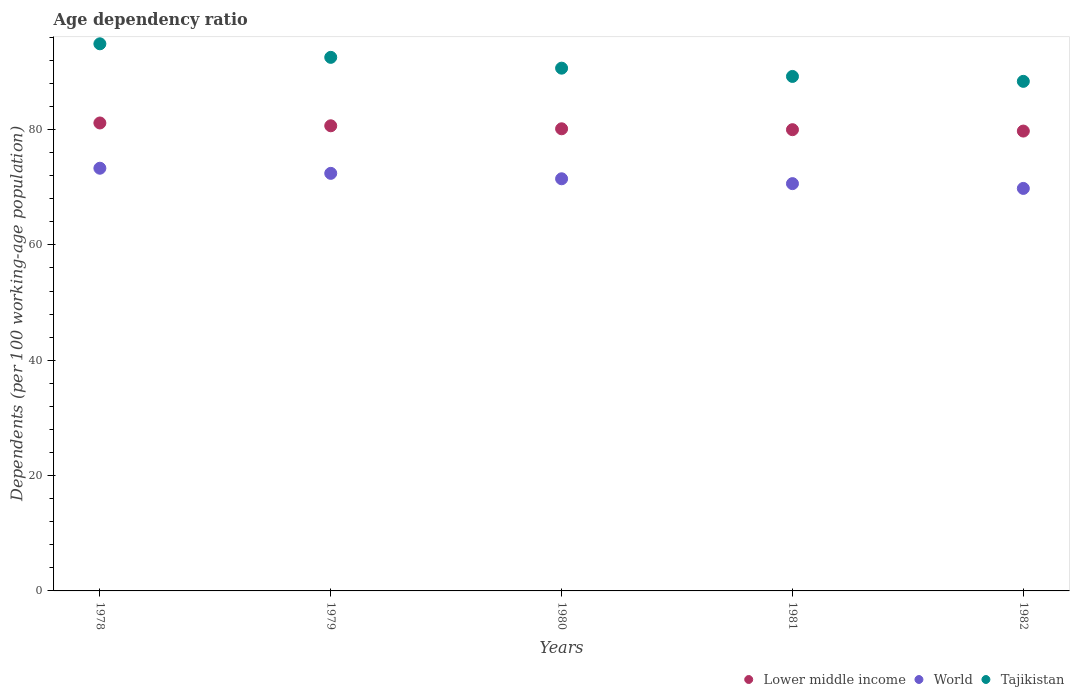What is the age dependency ratio in in Tajikistan in 1979?
Provide a short and direct response. 92.51. Across all years, what is the maximum age dependency ratio in in Tajikistan?
Ensure brevity in your answer.  94.86. Across all years, what is the minimum age dependency ratio in in Lower middle income?
Your answer should be compact. 79.73. In which year was the age dependency ratio in in Tajikistan maximum?
Keep it short and to the point. 1978. In which year was the age dependency ratio in in Tajikistan minimum?
Keep it short and to the point. 1982. What is the total age dependency ratio in in World in the graph?
Provide a succinct answer. 357.56. What is the difference between the age dependency ratio in in Tajikistan in 1980 and that in 1982?
Keep it short and to the point. 2.29. What is the difference between the age dependency ratio in in Lower middle income in 1978 and the age dependency ratio in in Tajikistan in 1982?
Your answer should be compact. -7.22. What is the average age dependency ratio in in Lower middle income per year?
Keep it short and to the point. 80.32. In the year 1981, what is the difference between the age dependency ratio in in Lower middle income and age dependency ratio in in World?
Your answer should be very brief. 9.35. What is the ratio of the age dependency ratio in in Tajikistan in 1980 to that in 1981?
Offer a terse response. 1.02. Is the difference between the age dependency ratio in in Lower middle income in 1978 and 1980 greater than the difference between the age dependency ratio in in World in 1978 and 1980?
Make the answer very short. No. What is the difference between the highest and the second highest age dependency ratio in in Tajikistan?
Your answer should be very brief. 2.35. What is the difference between the highest and the lowest age dependency ratio in in World?
Offer a very short reply. 3.5. In how many years, is the age dependency ratio in in Tajikistan greater than the average age dependency ratio in in Tajikistan taken over all years?
Provide a short and direct response. 2. Is the age dependency ratio in in World strictly greater than the age dependency ratio in in Tajikistan over the years?
Offer a terse response. No. Is the age dependency ratio in in Lower middle income strictly less than the age dependency ratio in in Tajikistan over the years?
Provide a succinct answer. Yes. How many dotlines are there?
Provide a succinct answer. 3. How many years are there in the graph?
Offer a terse response. 5. Does the graph contain grids?
Your answer should be compact. No. Where does the legend appear in the graph?
Offer a terse response. Bottom right. How are the legend labels stacked?
Make the answer very short. Horizontal. What is the title of the graph?
Make the answer very short. Age dependency ratio. What is the label or title of the X-axis?
Your response must be concise. Years. What is the label or title of the Y-axis?
Keep it short and to the point. Dependents (per 100 working-age population). What is the Dependents (per 100 working-age population) of Lower middle income in 1978?
Your answer should be very brief. 81.14. What is the Dependents (per 100 working-age population) of World in 1978?
Make the answer very short. 73.29. What is the Dependents (per 100 working-age population) of Tajikistan in 1978?
Offer a terse response. 94.86. What is the Dependents (per 100 working-age population) of Lower middle income in 1979?
Offer a very short reply. 80.65. What is the Dependents (per 100 working-age population) of World in 1979?
Your answer should be compact. 72.4. What is the Dependents (per 100 working-age population) in Tajikistan in 1979?
Keep it short and to the point. 92.51. What is the Dependents (per 100 working-age population) of Lower middle income in 1980?
Ensure brevity in your answer.  80.13. What is the Dependents (per 100 working-age population) of World in 1980?
Provide a succinct answer. 71.46. What is the Dependents (per 100 working-age population) in Tajikistan in 1980?
Your answer should be compact. 90.64. What is the Dependents (per 100 working-age population) of Lower middle income in 1981?
Your response must be concise. 79.97. What is the Dependents (per 100 working-age population) of World in 1981?
Provide a succinct answer. 70.62. What is the Dependents (per 100 working-age population) of Tajikistan in 1981?
Give a very brief answer. 89.2. What is the Dependents (per 100 working-age population) in Lower middle income in 1982?
Offer a terse response. 79.73. What is the Dependents (per 100 working-age population) in World in 1982?
Make the answer very short. 69.79. What is the Dependents (per 100 working-age population) of Tajikistan in 1982?
Make the answer very short. 88.35. Across all years, what is the maximum Dependents (per 100 working-age population) of Lower middle income?
Your answer should be compact. 81.14. Across all years, what is the maximum Dependents (per 100 working-age population) of World?
Your answer should be compact. 73.29. Across all years, what is the maximum Dependents (per 100 working-age population) of Tajikistan?
Keep it short and to the point. 94.86. Across all years, what is the minimum Dependents (per 100 working-age population) of Lower middle income?
Offer a terse response. 79.73. Across all years, what is the minimum Dependents (per 100 working-age population) of World?
Your answer should be compact. 69.79. Across all years, what is the minimum Dependents (per 100 working-age population) in Tajikistan?
Keep it short and to the point. 88.35. What is the total Dependents (per 100 working-age population) in Lower middle income in the graph?
Provide a succinct answer. 401.61. What is the total Dependents (per 100 working-age population) in World in the graph?
Offer a terse response. 357.56. What is the total Dependents (per 100 working-age population) in Tajikistan in the graph?
Provide a short and direct response. 455.57. What is the difference between the Dependents (per 100 working-age population) of Lower middle income in 1978 and that in 1979?
Provide a short and direct response. 0.49. What is the difference between the Dependents (per 100 working-age population) of World in 1978 and that in 1979?
Your answer should be compact. 0.89. What is the difference between the Dependents (per 100 working-age population) of Tajikistan in 1978 and that in 1979?
Your answer should be compact. 2.35. What is the difference between the Dependents (per 100 working-age population) in Lower middle income in 1978 and that in 1980?
Your answer should be compact. 1.01. What is the difference between the Dependents (per 100 working-age population) of World in 1978 and that in 1980?
Offer a very short reply. 1.83. What is the difference between the Dependents (per 100 working-age population) in Tajikistan in 1978 and that in 1980?
Offer a terse response. 4.22. What is the difference between the Dependents (per 100 working-age population) in Lower middle income in 1978 and that in 1981?
Offer a very short reply. 1.16. What is the difference between the Dependents (per 100 working-age population) of World in 1978 and that in 1981?
Provide a succinct answer. 2.67. What is the difference between the Dependents (per 100 working-age population) in Tajikistan in 1978 and that in 1981?
Your response must be concise. 5.66. What is the difference between the Dependents (per 100 working-age population) of Lower middle income in 1978 and that in 1982?
Your answer should be very brief. 1.41. What is the difference between the Dependents (per 100 working-age population) in Tajikistan in 1978 and that in 1982?
Provide a short and direct response. 6.51. What is the difference between the Dependents (per 100 working-age population) of Lower middle income in 1979 and that in 1980?
Give a very brief answer. 0.52. What is the difference between the Dependents (per 100 working-age population) in World in 1979 and that in 1980?
Give a very brief answer. 0.94. What is the difference between the Dependents (per 100 working-age population) of Tajikistan in 1979 and that in 1980?
Keep it short and to the point. 1.88. What is the difference between the Dependents (per 100 working-age population) of Lower middle income in 1979 and that in 1981?
Offer a very short reply. 0.68. What is the difference between the Dependents (per 100 working-age population) of World in 1979 and that in 1981?
Keep it short and to the point. 1.78. What is the difference between the Dependents (per 100 working-age population) of Tajikistan in 1979 and that in 1981?
Your response must be concise. 3.31. What is the difference between the Dependents (per 100 working-age population) of Lower middle income in 1979 and that in 1982?
Offer a terse response. 0.92. What is the difference between the Dependents (per 100 working-age population) in World in 1979 and that in 1982?
Provide a short and direct response. 2.61. What is the difference between the Dependents (per 100 working-age population) in Tajikistan in 1979 and that in 1982?
Offer a terse response. 4.16. What is the difference between the Dependents (per 100 working-age population) of Lower middle income in 1980 and that in 1981?
Your response must be concise. 0.15. What is the difference between the Dependents (per 100 working-age population) of World in 1980 and that in 1981?
Your answer should be very brief. 0.84. What is the difference between the Dependents (per 100 working-age population) in Tajikistan in 1980 and that in 1981?
Keep it short and to the point. 1.43. What is the difference between the Dependents (per 100 working-age population) of Lower middle income in 1980 and that in 1982?
Give a very brief answer. 0.4. What is the difference between the Dependents (per 100 working-age population) in World in 1980 and that in 1982?
Give a very brief answer. 1.67. What is the difference between the Dependents (per 100 working-age population) of Tajikistan in 1980 and that in 1982?
Your answer should be very brief. 2.29. What is the difference between the Dependents (per 100 working-age population) of Lower middle income in 1981 and that in 1982?
Provide a short and direct response. 0.24. What is the difference between the Dependents (per 100 working-age population) in World in 1981 and that in 1982?
Keep it short and to the point. 0.83. What is the difference between the Dependents (per 100 working-age population) in Tajikistan in 1981 and that in 1982?
Your response must be concise. 0.85. What is the difference between the Dependents (per 100 working-age population) of Lower middle income in 1978 and the Dependents (per 100 working-age population) of World in 1979?
Your answer should be very brief. 8.74. What is the difference between the Dependents (per 100 working-age population) of Lower middle income in 1978 and the Dependents (per 100 working-age population) of Tajikistan in 1979?
Give a very brief answer. -11.38. What is the difference between the Dependents (per 100 working-age population) of World in 1978 and the Dependents (per 100 working-age population) of Tajikistan in 1979?
Keep it short and to the point. -19.23. What is the difference between the Dependents (per 100 working-age population) of Lower middle income in 1978 and the Dependents (per 100 working-age population) of World in 1980?
Your answer should be compact. 9.68. What is the difference between the Dependents (per 100 working-age population) in Lower middle income in 1978 and the Dependents (per 100 working-age population) in Tajikistan in 1980?
Make the answer very short. -9.5. What is the difference between the Dependents (per 100 working-age population) of World in 1978 and the Dependents (per 100 working-age population) of Tajikistan in 1980?
Keep it short and to the point. -17.35. What is the difference between the Dependents (per 100 working-age population) of Lower middle income in 1978 and the Dependents (per 100 working-age population) of World in 1981?
Give a very brief answer. 10.52. What is the difference between the Dependents (per 100 working-age population) of Lower middle income in 1978 and the Dependents (per 100 working-age population) of Tajikistan in 1981?
Offer a very short reply. -8.07. What is the difference between the Dependents (per 100 working-age population) in World in 1978 and the Dependents (per 100 working-age population) in Tajikistan in 1981?
Make the answer very short. -15.92. What is the difference between the Dependents (per 100 working-age population) of Lower middle income in 1978 and the Dependents (per 100 working-age population) of World in 1982?
Provide a succinct answer. 11.35. What is the difference between the Dependents (per 100 working-age population) of Lower middle income in 1978 and the Dependents (per 100 working-age population) of Tajikistan in 1982?
Your answer should be very brief. -7.22. What is the difference between the Dependents (per 100 working-age population) of World in 1978 and the Dependents (per 100 working-age population) of Tajikistan in 1982?
Your response must be concise. -15.06. What is the difference between the Dependents (per 100 working-age population) of Lower middle income in 1979 and the Dependents (per 100 working-age population) of World in 1980?
Offer a terse response. 9.19. What is the difference between the Dependents (per 100 working-age population) in Lower middle income in 1979 and the Dependents (per 100 working-age population) in Tajikistan in 1980?
Your response must be concise. -9.99. What is the difference between the Dependents (per 100 working-age population) in World in 1979 and the Dependents (per 100 working-age population) in Tajikistan in 1980?
Your answer should be compact. -18.24. What is the difference between the Dependents (per 100 working-age population) of Lower middle income in 1979 and the Dependents (per 100 working-age population) of World in 1981?
Offer a very short reply. 10.03. What is the difference between the Dependents (per 100 working-age population) of Lower middle income in 1979 and the Dependents (per 100 working-age population) of Tajikistan in 1981?
Provide a short and direct response. -8.56. What is the difference between the Dependents (per 100 working-age population) in World in 1979 and the Dependents (per 100 working-age population) in Tajikistan in 1981?
Your response must be concise. -16.8. What is the difference between the Dependents (per 100 working-age population) in Lower middle income in 1979 and the Dependents (per 100 working-age population) in World in 1982?
Make the answer very short. 10.86. What is the difference between the Dependents (per 100 working-age population) in Lower middle income in 1979 and the Dependents (per 100 working-age population) in Tajikistan in 1982?
Offer a very short reply. -7.7. What is the difference between the Dependents (per 100 working-age population) in World in 1979 and the Dependents (per 100 working-age population) in Tajikistan in 1982?
Keep it short and to the point. -15.95. What is the difference between the Dependents (per 100 working-age population) of Lower middle income in 1980 and the Dependents (per 100 working-age population) of World in 1981?
Your answer should be very brief. 9.51. What is the difference between the Dependents (per 100 working-age population) in Lower middle income in 1980 and the Dependents (per 100 working-age population) in Tajikistan in 1981?
Offer a terse response. -9.08. What is the difference between the Dependents (per 100 working-age population) in World in 1980 and the Dependents (per 100 working-age population) in Tajikistan in 1981?
Your answer should be compact. -17.75. What is the difference between the Dependents (per 100 working-age population) of Lower middle income in 1980 and the Dependents (per 100 working-age population) of World in 1982?
Provide a short and direct response. 10.34. What is the difference between the Dependents (per 100 working-age population) in Lower middle income in 1980 and the Dependents (per 100 working-age population) in Tajikistan in 1982?
Your response must be concise. -8.22. What is the difference between the Dependents (per 100 working-age population) in World in 1980 and the Dependents (per 100 working-age population) in Tajikistan in 1982?
Offer a terse response. -16.89. What is the difference between the Dependents (per 100 working-age population) of Lower middle income in 1981 and the Dependents (per 100 working-age population) of World in 1982?
Provide a succinct answer. 10.18. What is the difference between the Dependents (per 100 working-age population) in Lower middle income in 1981 and the Dependents (per 100 working-age population) in Tajikistan in 1982?
Give a very brief answer. -8.38. What is the difference between the Dependents (per 100 working-age population) of World in 1981 and the Dependents (per 100 working-age population) of Tajikistan in 1982?
Your response must be concise. -17.73. What is the average Dependents (per 100 working-age population) in Lower middle income per year?
Your answer should be compact. 80.32. What is the average Dependents (per 100 working-age population) of World per year?
Provide a succinct answer. 71.51. What is the average Dependents (per 100 working-age population) in Tajikistan per year?
Your response must be concise. 91.11. In the year 1978, what is the difference between the Dependents (per 100 working-age population) of Lower middle income and Dependents (per 100 working-age population) of World?
Your answer should be very brief. 7.85. In the year 1978, what is the difference between the Dependents (per 100 working-age population) in Lower middle income and Dependents (per 100 working-age population) in Tajikistan?
Your answer should be compact. -13.73. In the year 1978, what is the difference between the Dependents (per 100 working-age population) in World and Dependents (per 100 working-age population) in Tajikistan?
Offer a very short reply. -21.57. In the year 1979, what is the difference between the Dependents (per 100 working-age population) in Lower middle income and Dependents (per 100 working-age population) in World?
Your response must be concise. 8.25. In the year 1979, what is the difference between the Dependents (per 100 working-age population) in Lower middle income and Dependents (per 100 working-age population) in Tajikistan?
Your answer should be compact. -11.87. In the year 1979, what is the difference between the Dependents (per 100 working-age population) of World and Dependents (per 100 working-age population) of Tajikistan?
Keep it short and to the point. -20.11. In the year 1980, what is the difference between the Dependents (per 100 working-age population) in Lower middle income and Dependents (per 100 working-age population) in World?
Offer a very short reply. 8.67. In the year 1980, what is the difference between the Dependents (per 100 working-age population) in Lower middle income and Dependents (per 100 working-age population) in Tajikistan?
Your response must be concise. -10.51. In the year 1980, what is the difference between the Dependents (per 100 working-age population) in World and Dependents (per 100 working-age population) in Tajikistan?
Your answer should be very brief. -19.18. In the year 1981, what is the difference between the Dependents (per 100 working-age population) in Lower middle income and Dependents (per 100 working-age population) in World?
Make the answer very short. 9.35. In the year 1981, what is the difference between the Dependents (per 100 working-age population) of Lower middle income and Dependents (per 100 working-age population) of Tajikistan?
Your answer should be very brief. -9.23. In the year 1981, what is the difference between the Dependents (per 100 working-age population) of World and Dependents (per 100 working-age population) of Tajikistan?
Your answer should be very brief. -18.59. In the year 1982, what is the difference between the Dependents (per 100 working-age population) of Lower middle income and Dependents (per 100 working-age population) of World?
Make the answer very short. 9.94. In the year 1982, what is the difference between the Dependents (per 100 working-age population) of Lower middle income and Dependents (per 100 working-age population) of Tajikistan?
Provide a succinct answer. -8.62. In the year 1982, what is the difference between the Dependents (per 100 working-age population) of World and Dependents (per 100 working-age population) of Tajikistan?
Keep it short and to the point. -18.56. What is the ratio of the Dependents (per 100 working-age population) in Lower middle income in 1978 to that in 1979?
Your answer should be very brief. 1.01. What is the ratio of the Dependents (per 100 working-age population) of World in 1978 to that in 1979?
Your answer should be very brief. 1.01. What is the ratio of the Dependents (per 100 working-age population) in Tajikistan in 1978 to that in 1979?
Your response must be concise. 1.03. What is the ratio of the Dependents (per 100 working-age population) in Lower middle income in 1978 to that in 1980?
Your response must be concise. 1.01. What is the ratio of the Dependents (per 100 working-age population) in World in 1978 to that in 1980?
Your response must be concise. 1.03. What is the ratio of the Dependents (per 100 working-age population) in Tajikistan in 1978 to that in 1980?
Make the answer very short. 1.05. What is the ratio of the Dependents (per 100 working-age population) of Lower middle income in 1978 to that in 1981?
Offer a terse response. 1.01. What is the ratio of the Dependents (per 100 working-age population) of World in 1978 to that in 1981?
Your answer should be very brief. 1.04. What is the ratio of the Dependents (per 100 working-age population) of Tajikistan in 1978 to that in 1981?
Ensure brevity in your answer.  1.06. What is the ratio of the Dependents (per 100 working-age population) in Lower middle income in 1978 to that in 1982?
Offer a very short reply. 1.02. What is the ratio of the Dependents (per 100 working-age population) in World in 1978 to that in 1982?
Keep it short and to the point. 1.05. What is the ratio of the Dependents (per 100 working-age population) of Tajikistan in 1978 to that in 1982?
Give a very brief answer. 1.07. What is the ratio of the Dependents (per 100 working-age population) in Lower middle income in 1979 to that in 1980?
Your answer should be compact. 1.01. What is the ratio of the Dependents (per 100 working-age population) in World in 1979 to that in 1980?
Offer a terse response. 1.01. What is the ratio of the Dependents (per 100 working-age population) in Tajikistan in 1979 to that in 1980?
Offer a terse response. 1.02. What is the ratio of the Dependents (per 100 working-age population) of Lower middle income in 1979 to that in 1981?
Provide a succinct answer. 1.01. What is the ratio of the Dependents (per 100 working-age population) in World in 1979 to that in 1981?
Your answer should be very brief. 1.03. What is the ratio of the Dependents (per 100 working-age population) of Tajikistan in 1979 to that in 1981?
Your answer should be compact. 1.04. What is the ratio of the Dependents (per 100 working-age population) of Lower middle income in 1979 to that in 1982?
Offer a very short reply. 1.01. What is the ratio of the Dependents (per 100 working-age population) of World in 1979 to that in 1982?
Keep it short and to the point. 1.04. What is the ratio of the Dependents (per 100 working-age population) in Tajikistan in 1979 to that in 1982?
Make the answer very short. 1.05. What is the ratio of the Dependents (per 100 working-age population) of World in 1980 to that in 1981?
Your response must be concise. 1.01. What is the ratio of the Dependents (per 100 working-age population) in Tajikistan in 1980 to that in 1981?
Offer a very short reply. 1.02. What is the ratio of the Dependents (per 100 working-age population) of World in 1980 to that in 1982?
Your answer should be compact. 1.02. What is the ratio of the Dependents (per 100 working-age population) in Tajikistan in 1980 to that in 1982?
Keep it short and to the point. 1.03. What is the ratio of the Dependents (per 100 working-age population) in World in 1981 to that in 1982?
Offer a terse response. 1.01. What is the ratio of the Dependents (per 100 working-age population) in Tajikistan in 1981 to that in 1982?
Make the answer very short. 1.01. What is the difference between the highest and the second highest Dependents (per 100 working-age population) of Lower middle income?
Your answer should be compact. 0.49. What is the difference between the highest and the second highest Dependents (per 100 working-age population) in World?
Give a very brief answer. 0.89. What is the difference between the highest and the second highest Dependents (per 100 working-age population) in Tajikistan?
Make the answer very short. 2.35. What is the difference between the highest and the lowest Dependents (per 100 working-age population) in Lower middle income?
Offer a terse response. 1.41. What is the difference between the highest and the lowest Dependents (per 100 working-age population) of Tajikistan?
Give a very brief answer. 6.51. 